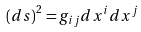Convert formula to latex. <formula><loc_0><loc_0><loc_500><loc_500>\left ( d s \right ) ^ { 2 } = g _ { i j } d x ^ { i } d x ^ { j }</formula> 